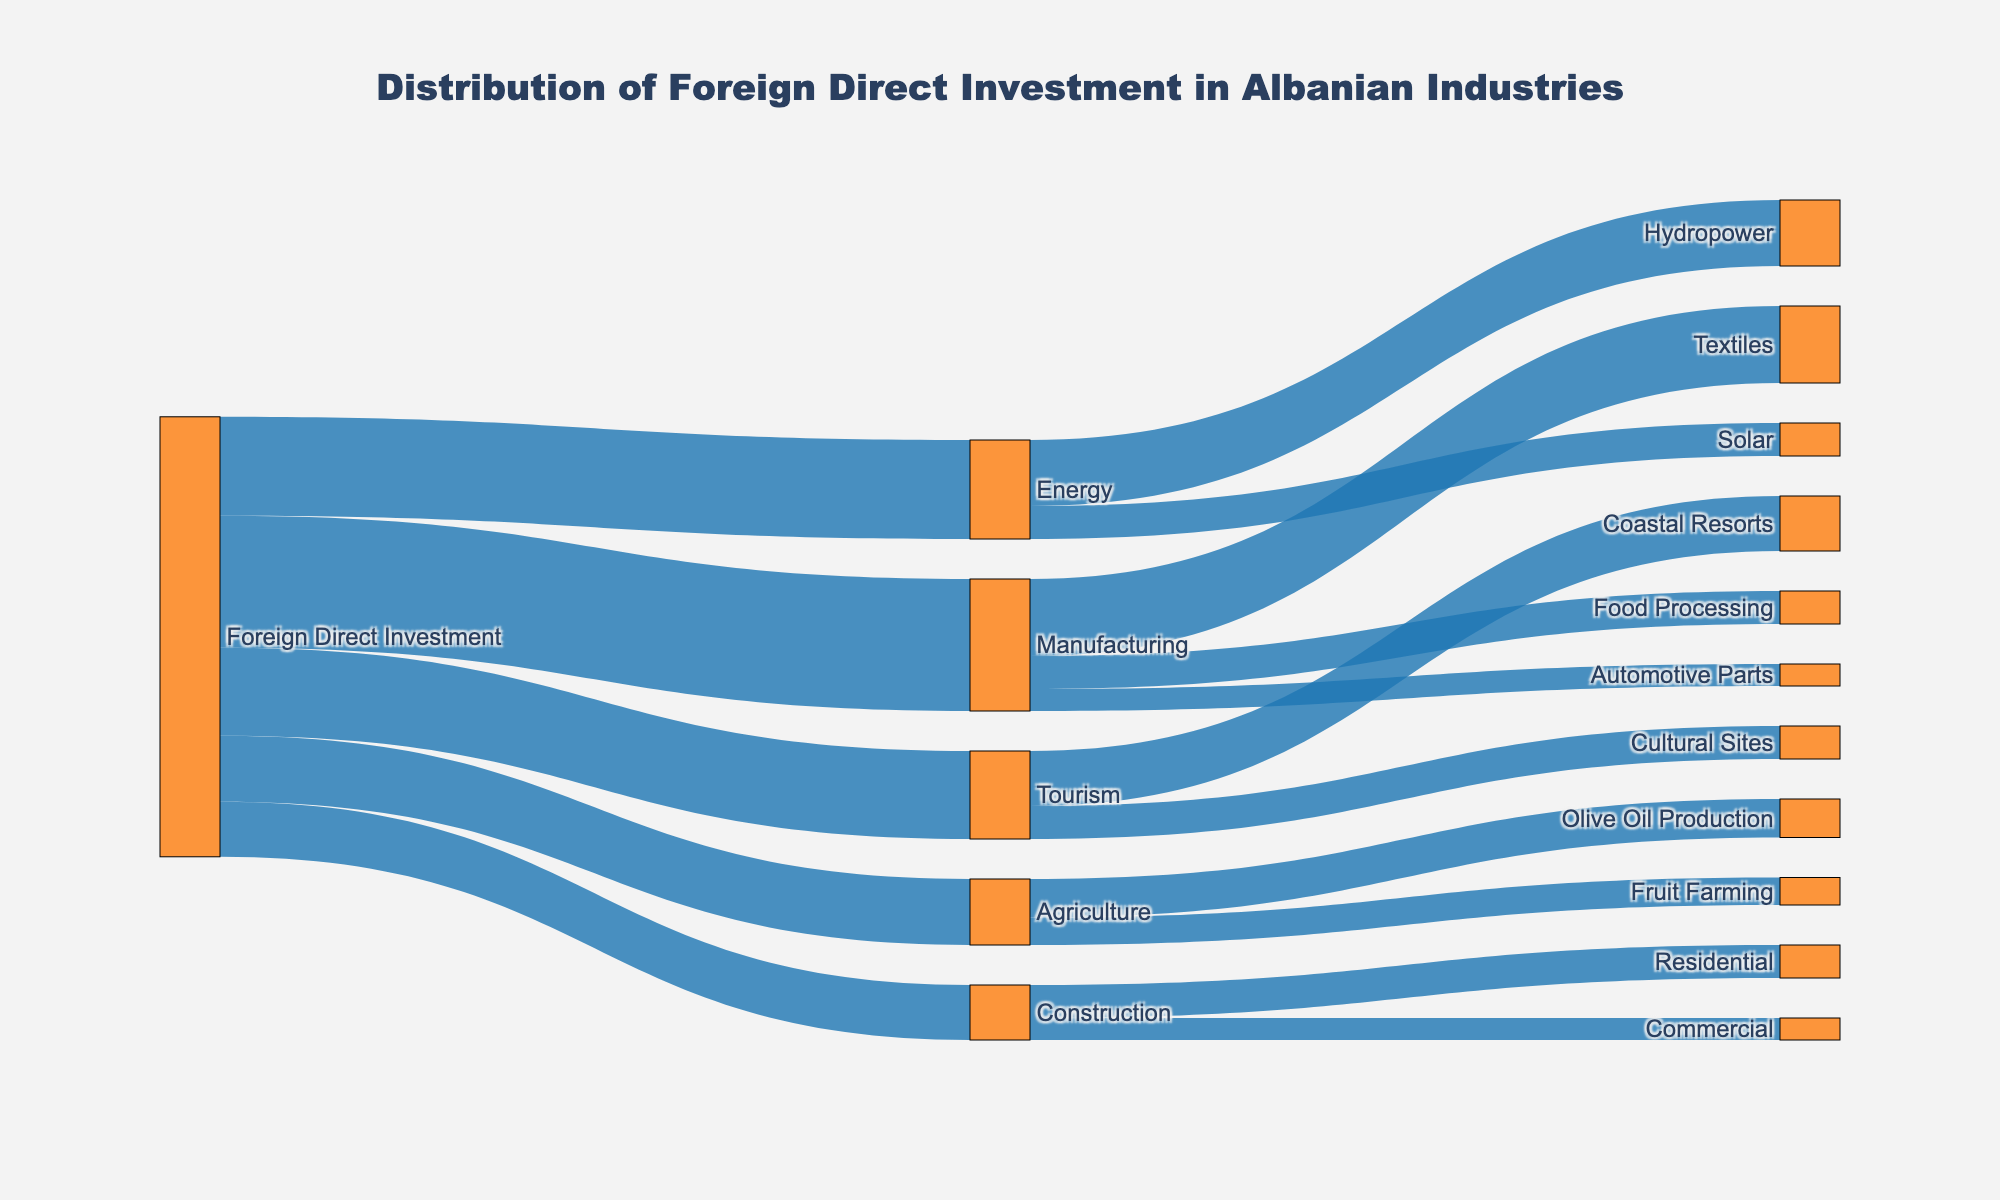What is the title of the diagram? The title of the diagram is positioned at the top and can be easily read from the visual.
Answer: Distribution of Foreign Direct Investment in Albanian Industries How much Foreign Direct Investment is allocated to the Manufacturing industry? Look at the first bar connecting 'Foreign Direct Investment' to 'Manufacturing' and read the value indicated.
Answer: 120 Which industry receives the least Foreign Direct Investment? Compare the values connected directly to 'Foreign Direct Investment' and identify the smallest value.
Answer: Construction What is the total Foreign Direct Investment in Energy plus Tourism? Sum the values from 'Foreign Direct Investment' to 'Energy' and 'Tourism'. 90 + 80.
Answer: 170 Which sub-category within Manufacturing receives the highest investment? Look at the branches connecting from 'Manufacturing' and identify the highest value.
Answer: Textiles How does the investment in Olive Oil Production compare to Fruit Farming in Agriculture? Compare the values flowing from 'Agriculture' to 'Olive Oil Production' and 'Fruit Farming'.
Answer: Olive Oil Production receives a higher investment (35 compared to 25) What percentage of the total Foreign Direct Investment is directed towards Manufacturing? Calculate the proportion of investment in Manufacturing out of the total Foreign Direct Investment. Total is 400, Manufacturing is 120. (120/400) x 100.
Answer: 30% Is the investment in Hydropower higher or lower than in Solar within the Energy sector? Compare the values from 'Energy' to 'Hydropower' and 'Solar'.
Answer: Higher What is the combined investment in the residential and commercial construction sectors? Sum the values for 'Residential' and 'Commercial' under the Construction sector. 30 + 20.
Answer: 50 If the Foreign Direct Investment were reassigned so that Agriculture received the most investment, how much more would it need to surpass Manufacturing? Subtract the value currently allocated to Agriculture from the value allocated to Manufacturing to find the difference. 120 - 60.
Answer: 60 